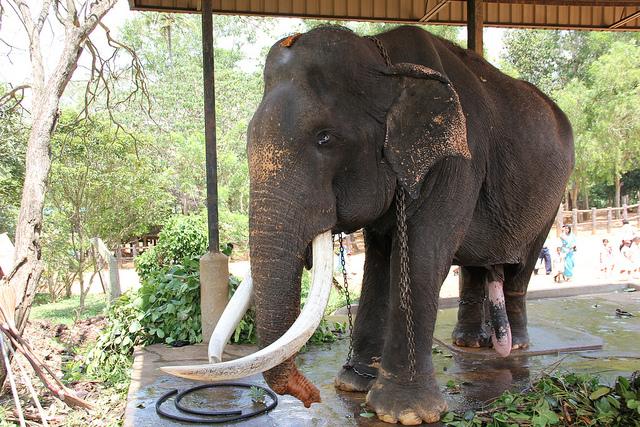Is the elephant sleeping?
Be succinct. No. What animal is in the picture?
Give a very brief answer. Elephant. Is the animal female?
Quick response, please. No. 